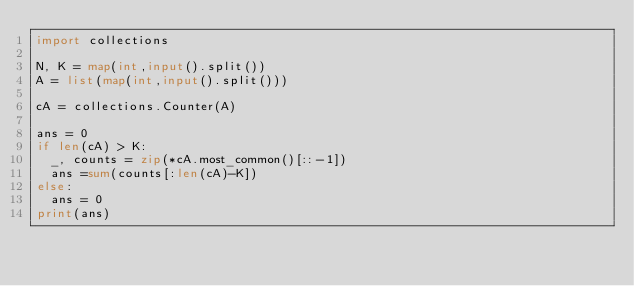<code> <loc_0><loc_0><loc_500><loc_500><_Python_>import collections

N, K = map(int,input().split())
A = list(map(int,input().split()))

cA = collections.Counter(A)

ans = 0
if len(cA) > K:
  _, counts = zip(*cA.most_common()[::-1])
  ans =sum(counts[:len(cA)-K])
else:
  ans = 0
print(ans)</code> 